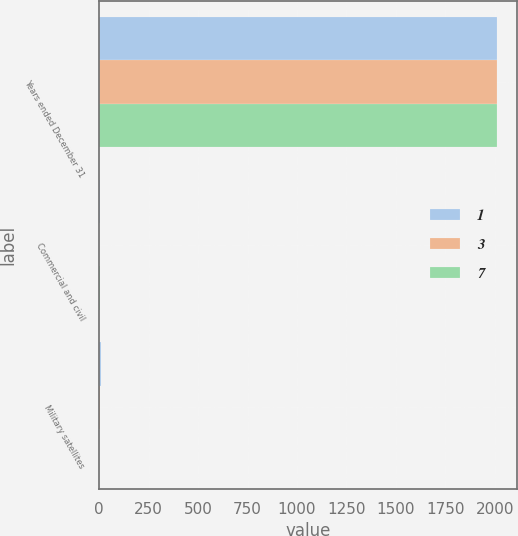Convert chart to OTSL. <chart><loc_0><loc_0><loc_500><loc_500><stacked_bar_chart><ecel><fcel>Years ended December 31<fcel>Commercial and civil<fcel>Military satellites<nl><fcel>1<fcel>2012<fcel>3<fcel>7<nl><fcel>3<fcel>2011<fcel>1<fcel>3<nl><fcel>7<fcel>2010<fcel>3<fcel>1<nl></chart> 